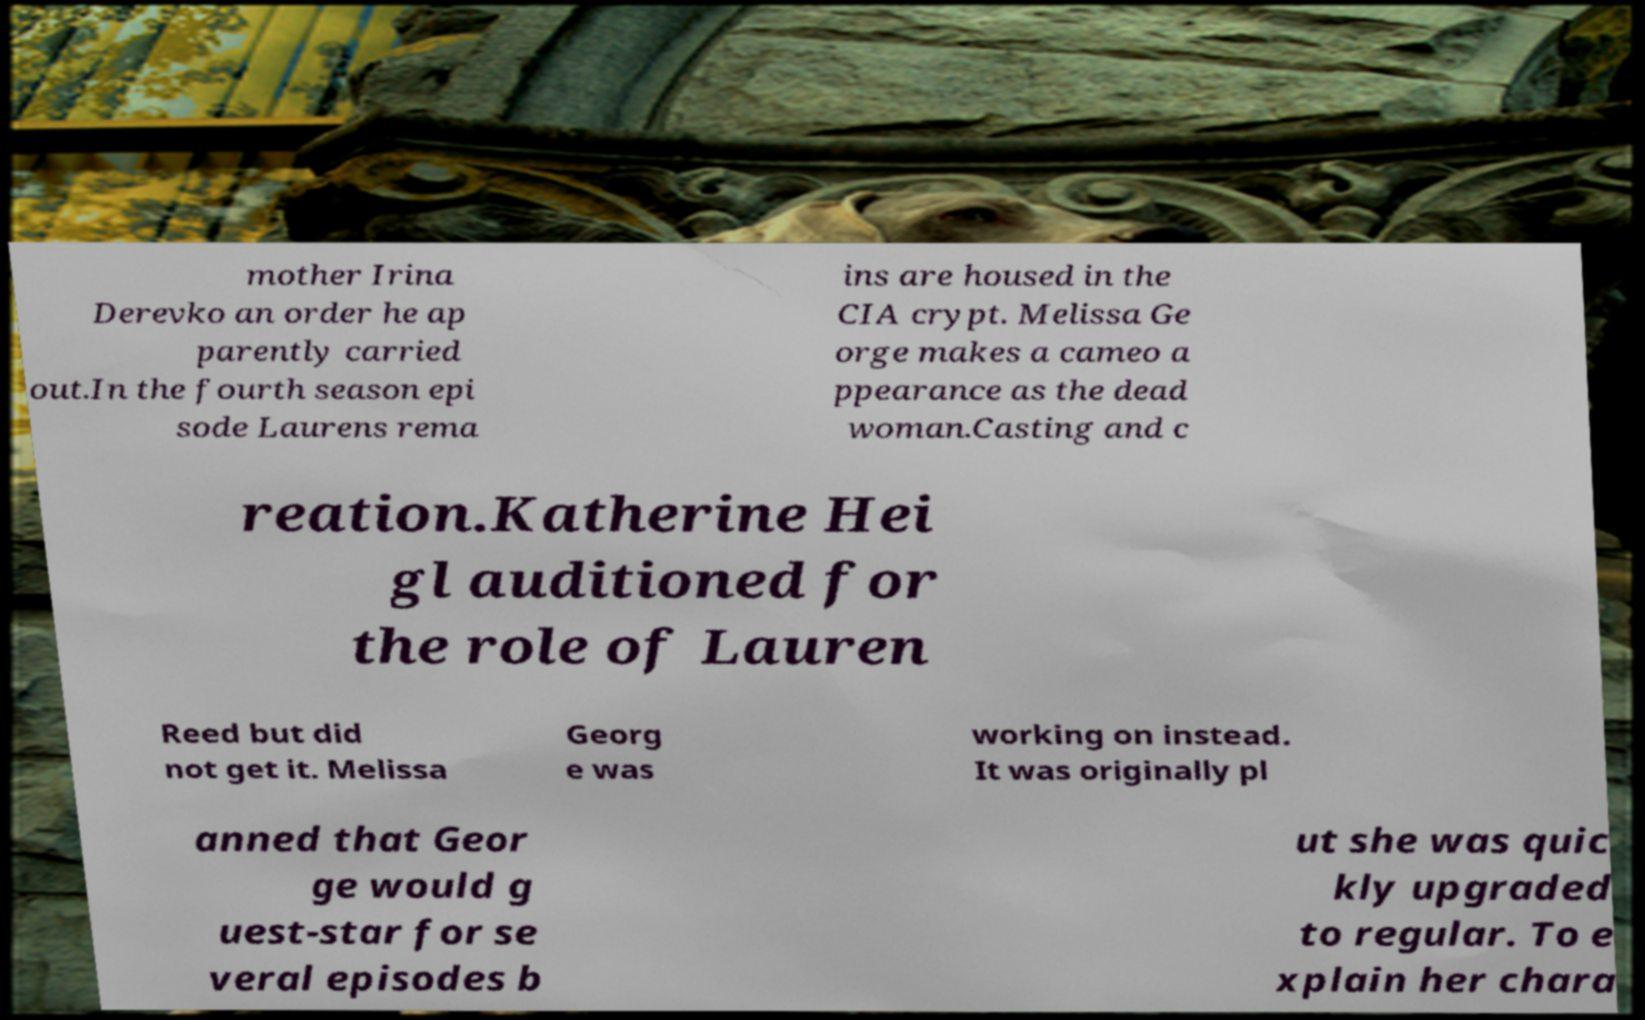Could you extract and type out the text from this image? mother Irina Derevko an order he ap parently carried out.In the fourth season epi sode Laurens rema ins are housed in the CIA crypt. Melissa Ge orge makes a cameo a ppearance as the dead woman.Casting and c reation.Katherine Hei gl auditioned for the role of Lauren Reed but did not get it. Melissa Georg e was working on instead. It was originally pl anned that Geor ge would g uest-star for se veral episodes b ut she was quic kly upgraded to regular. To e xplain her chara 